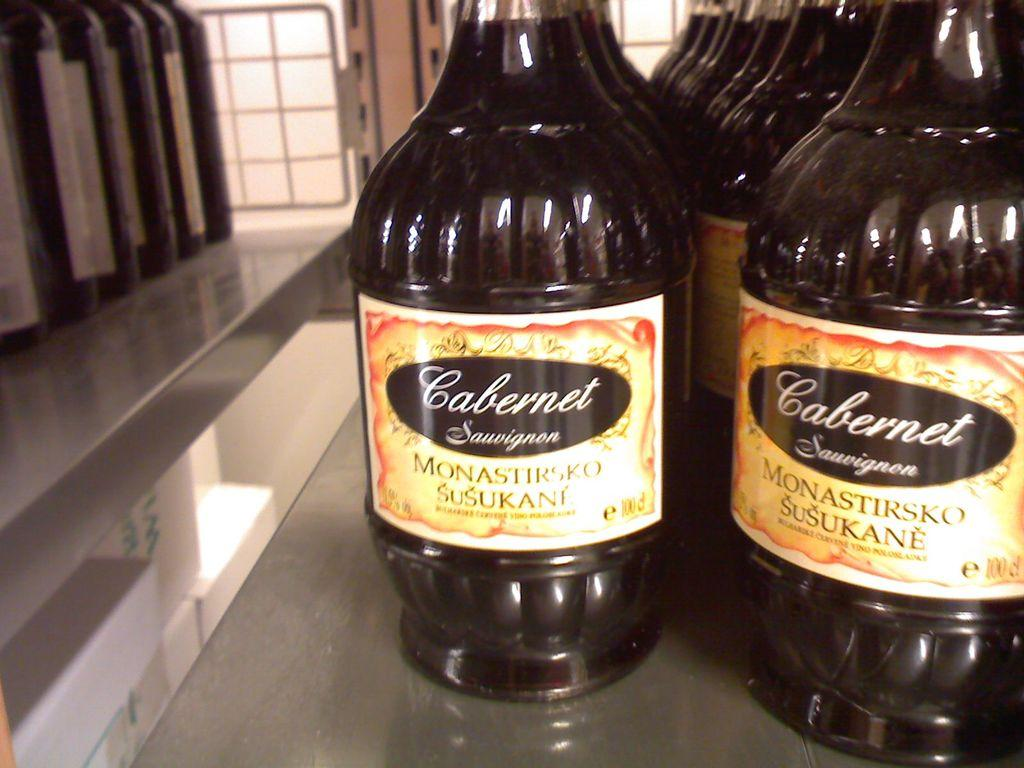<image>
Summarize the visual content of the image. Black bottles next to one another and has a sticker that says "CABERNET". 